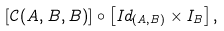<formula> <loc_0><loc_0><loc_500><loc_500>\left [ \mathcal { C } ( A , B , B ) \right ] \circ \left [ I d _ { ( A , B ) } \times I _ { B } \right ] ,</formula> 